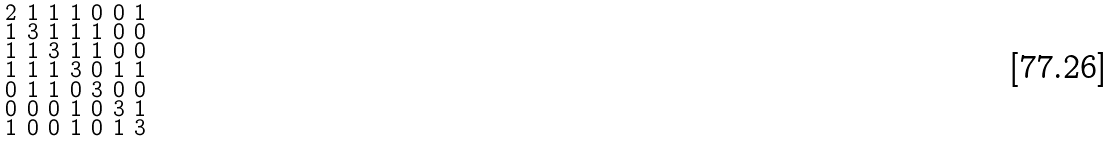<formula> <loc_0><loc_0><loc_500><loc_500>\begin{smallmatrix} 2 & 1 & 1 & 1 & 0 & 0 & 1 \\ 1 & 3 & 1 & 1 & 1 & 0 & 0 \\ 1 & 1 & 3 & 1 & 1 & 0 & 0 \\ 1 & 1 & 1 & 3 & 0 & 1 & 1 \\ 0 & 1 & 1 & 0 & 3 & 0 & 0 \\ 0 & 0 & 0 & 1 & 0 & 3 & 1 \\ 1 & 0 & 0 & 1 & 0 & 1 & 3 \end{smallmatrix}</formula> 